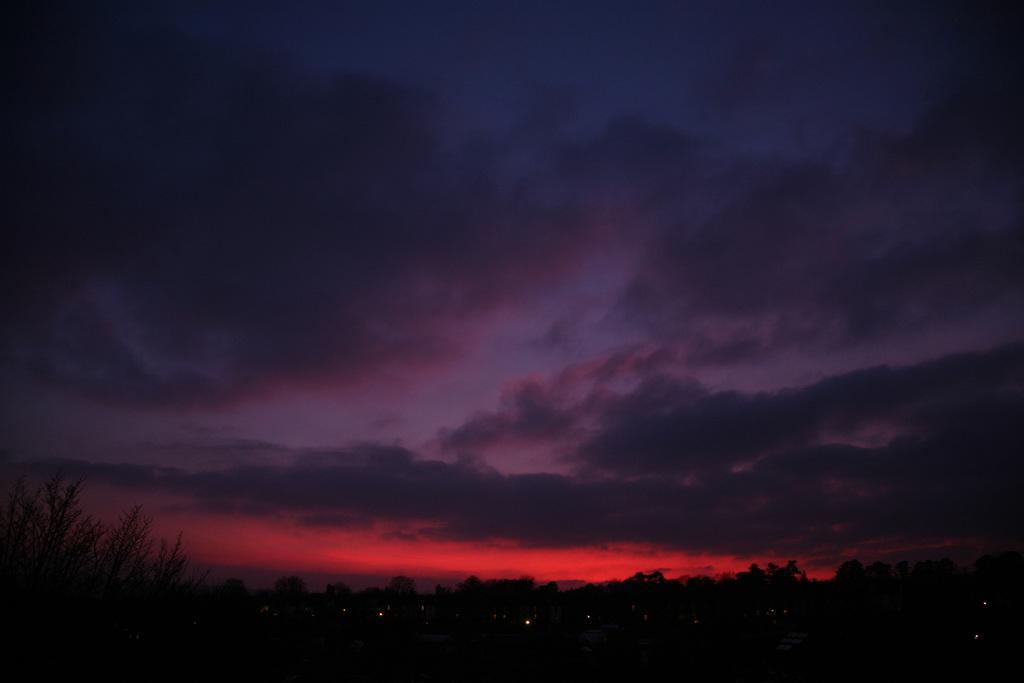Please provide a concise description of this image. These image is taken during evening. At the bottom of the image we can see trees. At the top of the image we can see sky and clouds and sunset. 